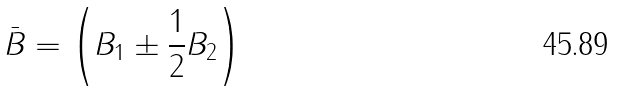<formula> <loc_0><loc_0><loc_500><loc_500>\bar { B } = \left ( B _ { 1 } \pm \frac { 1 } { 2 } B _ { 2 } \right )</formula> 